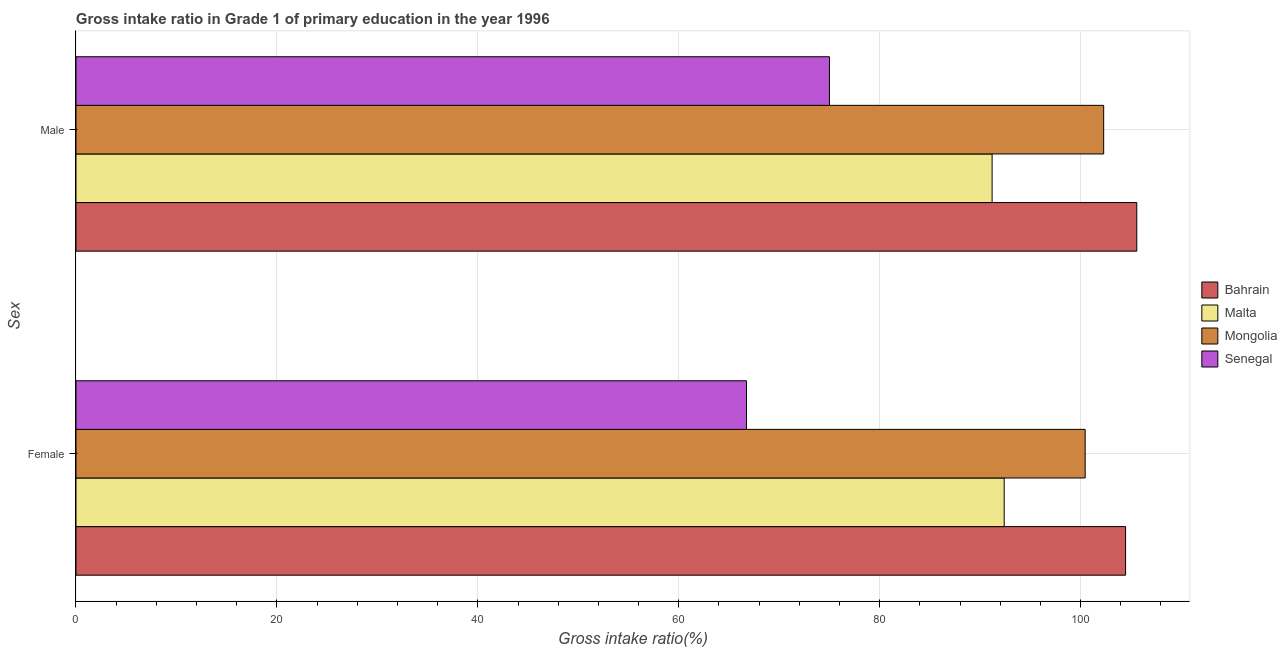How many groups of bars are there?
Make the answer very short. 2. Are the number of bars per tick equal to the number of legend labels?
Provide a short and direct response. Yes. Are the number of bars on each tick of the Y-axis equal?
Offer a very short reply. Yes. What is the label of the 1st group of bars from the top?
Your answer should be very brief. Male. What is the gross intake ratio(female) in Malta?
Provide a short and direct response. 92.39. Across all countries, what is the maximum gross intake ratio(female)?
Offer a terse response. 104.48. Across all countries, what is the minimum gross intake ratio(female)?
Provide a succinct answer. 66.74. In which country was the gross intake ratio(female) maximum?
Keep it short and to the point. Bahrain. In which country was the gross intake ratio(male) minimum?
Give a very brief answer. Senegal. What is the total gross intake ratio(female) in the graph?
Offer a terse response. 364.07. What is the difference between the gross intake ratio(female) in Bahrain and that in Senegal?
Provide a succinct answer. 37.74. What is the difference between the gross intake ratio(female) in Senegal and the gross intake ratio(male) in Bahrain?
Provide a short and direct response. -38.85. What is the average gross intake ratio(female) per country?
Provide a succinct answer. 91.02. What is the difference between the gross intake ratio(male) and gross intake ratio(female) in Bahrain?
Your response must be concise. 1.12. In how many countries, is the gross intake ratio(female) greater than 72 %?
Offer a very short reply. 3. What is the ratio of the gross intake ratio(female) in Mongolia to that in Senegal?
Give a very brief answer. 1.51. What does the 2nd bar from the top in Male represents?
Provide a succinct answer. Mongolia. What does the 1st bar from the bottom in Male represents?
Provide a succinct answer. Bahrain. How many bars are there?
Provide a short and direct response. 8. Are all the bars in the graph horizontal?
Offer a terse response. Yes. What is the difference between two consecutive major ticks on the X-axis?
Give a very brief answer. 20. Are the values on the major ticks of X-axis written in scientific E-notation?
Your answer should be very brief. No. Does the graph contain any zero values?
Offer a terse response. No. Does the graph contain grids?
Keep it short and to the point. Yes. Where does the legend appear in the graph?
Your answer should be very brief. Center right. How many legend labels are there?
Provide a short and direct response. 4. What is the title of the graph?
Your response must be concise. Gross intake ratio in Grade 1 of primary education in the year 1996. What is the label or title of the X-axis?
Provide a succinct answer. Gross intake ratio(%). What is the label or title of the Y-axis?
Ensure brevity in your answer.  Sex. What is the Gross intake ratio(%) of Bahrain in Female?
Your answer should be very brief. 104.48. What is the Gross intake ratio(%) of Malta in Female?
Provide a short and direct response. 92.39. What is the Gross intake ratio(%) of Mongolia in Female?
Keep it short and to the point. 100.46. What is the Gross intake ratio(%) of Senegal in Female?
Offer a terse response. 66.74. What is the Gross intake ratio(%) of Bahrain in Male?
Ensure brevity in your answer.  105.59. What is the Gross intake ratio(%) of Malta in Male?
Your response must be concise. 91.19. What is the Gross intake ratio(%) of Mongolia in Male?
Your answer should be very brief. 102.3. What is the Gross intake ratio(%) in Senegal in Male?
Offer a terse response. 75. Across all Sex, what is the maximum Gross intake ratio(%) of Bahrain?
Give a very brief answer. 105.59. Across all Sex, what is the maximum Gross intake ratio(%) of Malta?
Provide a succinct answer. 92.39. Across all Sex, what is the maximum Gross intake ratio(%) in Mongolia?
Provide a short and direct response. 102.3. Across all Sex, what is the maximum Gross intake ratio(%) of Senegal?
Provide a succinct answer. 75. Across all Sex, what is the minimum Gross intake ratio(%) in Bahrain?
Provide a short and direct response. 104.48. Across all Sex, what is the minimum Gross intake ratio(%) in Malta?
Provide a succinct answer. 91.19. Across all Sex, what is the minimum Gross intake ratio(%) in Mongolia?
Your answer should be compact. 100.46. Across all Sex, what is the minimum Gross intake ratio(%) of Senegal?
Your answer should be very brief. 66.74. What is the total Gross intake ratio(%) in Bahrain in the graph?
Your answer should be very brief. 210.07. What is the total Gross intake ratio(%) in Malta in the graph?
Keep it short and to the point. 183.59. What is the total Gross intake ratio(%) in Mongolia in the graph?
Keep it short and to the point. 202.75. What is the total Gross intake ratio(%) in Senegal in the graph?
Your answer should be very brief. 141.74. What is the difference between the Gross intake ratio(%) of Bahrain in Female and that in Male?
Ensure brevity in your answer.  -1.12. What is the difference between the Gross intake ratio(%) of Malta in Female and that in Male?
Your response must be concise. 1.2. What is the difference between the Gross intake ratio(%) of Mongolia in Female and that in Male?
Offer a terse response. -1.84. What is the difference between the Gross intake ratio(%) of Senegal in Female and that in Male?
Keep it short and to the point. -8.26. What is the difference between the Gross intake ratio(%) of Bahrain in Female and the Gross intake ratio(%) of Malta in Male?
Give a very brief answer. 13.28. What is the difference between the Gross intake ratio(%) in Bahrain in Female and the Gross intake ratio(%) in Mongolia in Male?
Your answer should be very brief. 2.18. What is the difference between the Gross intake ratio(%) of Bahrain in Female and the Gross intake ratio(%) of Senegal in Male?
Ensure brevity in your answer.  29.48. What is the difference between the Gross intake ratio(%) in Malta in Female and the Gross intake ratio(%) in Mongolia in Male?
Ensure brevity in your answer.  -9.9. What is the difference between the Gross intake ratio(%) of Malta in Female and the Gross intake ratio(%) of Senegal in Male?
Keep it short and to the point. 17.39. What is the difference between the Gross intake ratio(%) of Mongolia in Female and the Gross intake ratio(%) of Senegal in Male?
Your answer should be compact. 25.45. What is the average Gross intake ratio(%) in Bahrain per Sex?
Provide a succinct answer. 105.04. What is the average Gross intake ratio(%) in Malta per Sex?
Your answer should be compact. 91.79. What is the average Gross intake ratio(%) in Mongolia per Sex?
Offer a terse response. 101.38. What is the average Gross intake ratio(%) in Senegal per Sex?
Keep it short and to the point. 70.87. What is the difference between the Gross intake ratio(%) in Bahrain and Gross intake ratio(%) in Malta in Female?
Provide a succinct answer. 12.08. What is the difference between the Gross intake ratio(%) in Bahrain and Gross intake ratio(%) in Mongolia in Female?
Ensure brevity in your answer.  4.02. What is the difference between the Gross intake ratio(%) of Bahrain and Gross intake ratio(%) of Senegal in Female?
Offer a terse response. 37.74. What is the difference between the Gross intake ratio(%) in Malta and Gross intake ratio(%) in Mongolia in Female?
Your response must be concise. -8.06. What is the difference between the Gross intake ratio(%) of Malta and Gross intake ratio(%) of Senegal in Female?
Make the answer very short. 25.65. What is the difference between the Gross intake ratio(%) in Mongolia and Gross intake ratio(%) in Senegal in Female?
Provide a succinct answer. 33.72. What is the difference between the Gross intake ratio(%) of Bahrain and Gross intake ratio(%) of Malta in Male?
Make the answer very short. 14.4. What is the difference between the Gross intake ratio(%) in Bahrain and Gross intake ratio(%) in Mongolia in Male?
Your answer should be very brief. 3.3. What is the difference between the Gross intake ratio(%) of Bahrain and Gross intake ratio(%) of Senegal in Male?
Your answer should be compact. 30.59. What is the difference between the Gross intake ratio(%) in Malta and Gross intake ratio(%) in Mongolia in Male?
Provide a succinct answer. -11.1. What is the difference between the Gross intake ratio(%) of Malta and Gross intake ratio(%) of Senegal in Male?
Your answer should be very brief. 16.19. What is the difference between the Gross intake ratio(%) in Mongolia and Gross intake ratio(%) in Senegal in Male?
Ensure brevity in your answer.  27.29. What is the ratio of the Gross intake ratio(%) in Bahrain in Female to that in Male?
Your response must be concise. 0.99. What is the ratio of the Gross intake ratio(%) of Malta in Female to that in Male?
Provide a succinct answer. 1.01. What is the ratio of the Gross intake ratio(%) of Senegal in Female to that in Male?
Your answer should be very brief. 0.89. What is the difference between the highest and the second highest Gross intake ratio(%) of Bahrain?
Offer a very short reply. 1.12. What is the difference between the highest and the second highest Gross intake ratio(%) of Malta?
Make the answer very short. 1.2. What is the difference between the highest and the second highest Gross intake ratio(%) of Mongolia?
Offer a very short reply. 1.84. What is the difference between the highest and the second highest Gross intake ratio(%) of Senegal?
Your answer should be very brief. 8.26. What is the difference between the highest and the lowest Gross intake ratio(%) of Bahrain?
Ensure brevity in your answer.  1.12. What is the difference between the highest and the lowest Gross intake ratio(%) in Malta?
Make the answer very short. 1.2. What is the difference between the highest and the lowest Gross intake ratio(%) in Mongolia?
Provide a succinct answer. 1.84. What is the difference between the highest and the lowest Gross intake ratio(%) of Senegal?
Your answer should be very brief. 8.26. 